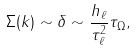Convert formula to latex. <formula><loc_0><loc_0><loc_500><loc_500>\Sigma ( k ) \sim \delta \sim \frac { h _ { \ell } } { \tau _ { \ell } ^ { 2 } } \tau _ { \Omega } ,</formula> 